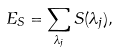<formula> <loc_0><loc_0><loc_500><loc_500>E _ { S } = \sum _ { \lambda _ { j } } S ( \lambda _ { j } ) ,</formula> 